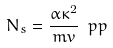<formula> <loc_0><loc_0><loc_500><loc_500>N _ { s } = \frac { \alpha \kappa ^ { 2 } } { m v } \ p p</formula> 